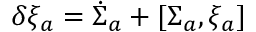<formula> <loc_0><loc_0><loc_500><loc_500>\delta \xi _ { a } = \dot { \Sigma } _ { a } + [ \Sigma _ { a } , \xi _ { a } ]</formula> 